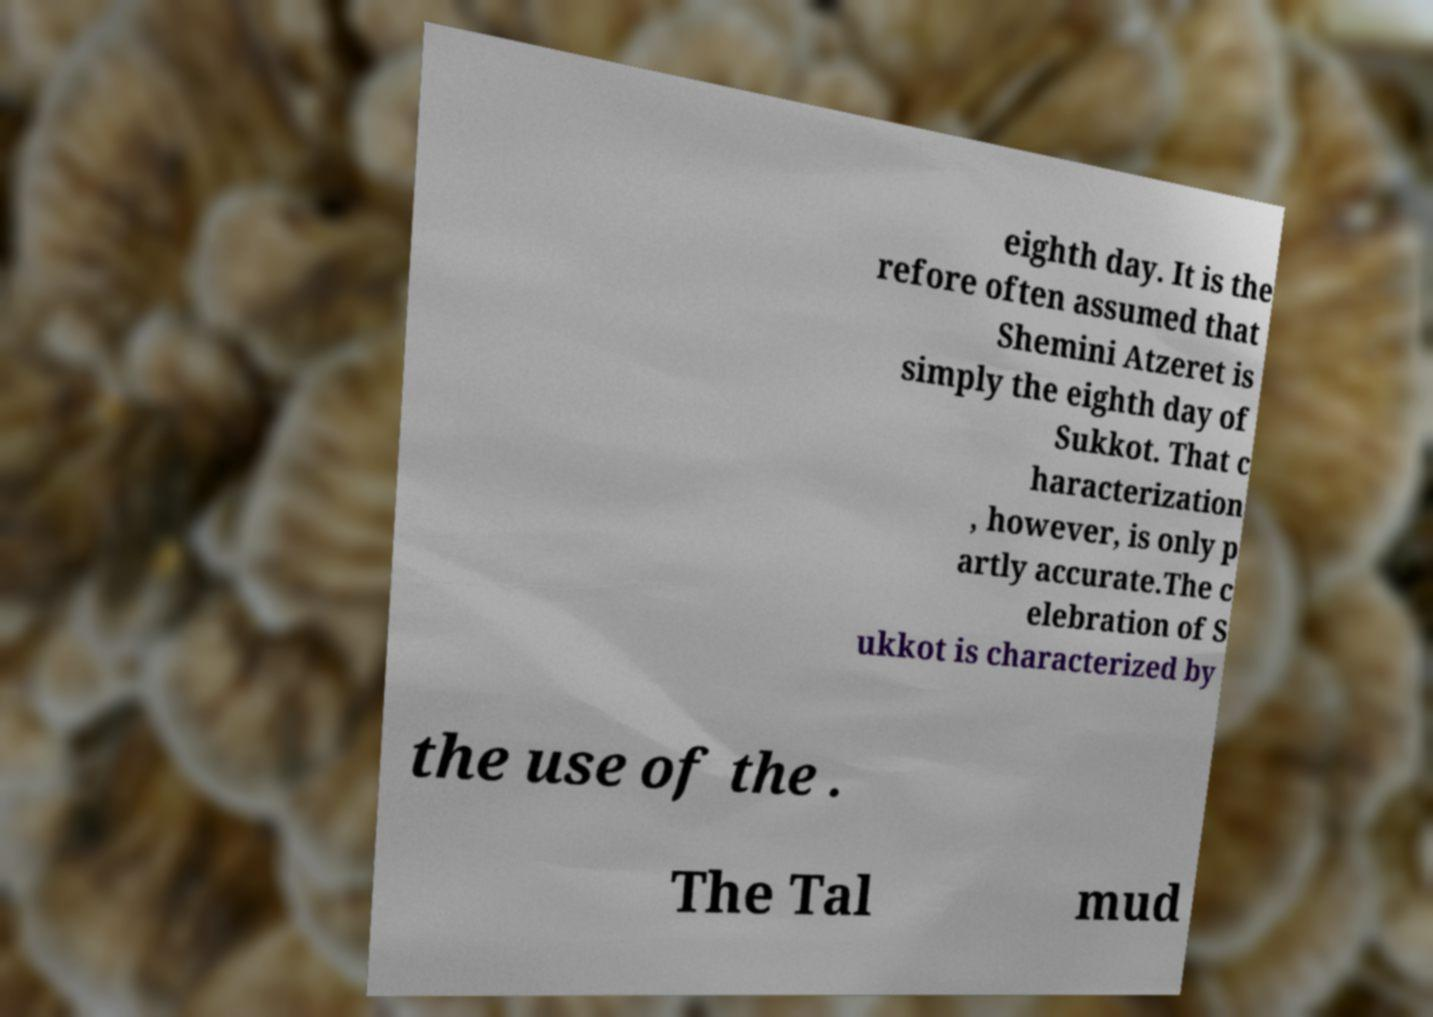Please identify and transcribe the text found in this image. eighth day. It is the refore often assumed that Shemini Atzeret is simply the eighth day of Sukkot. That c haracterization , however, is only p artly accurate.The c elebration of S ukkot is characterized by the use of the . The Tal mud 